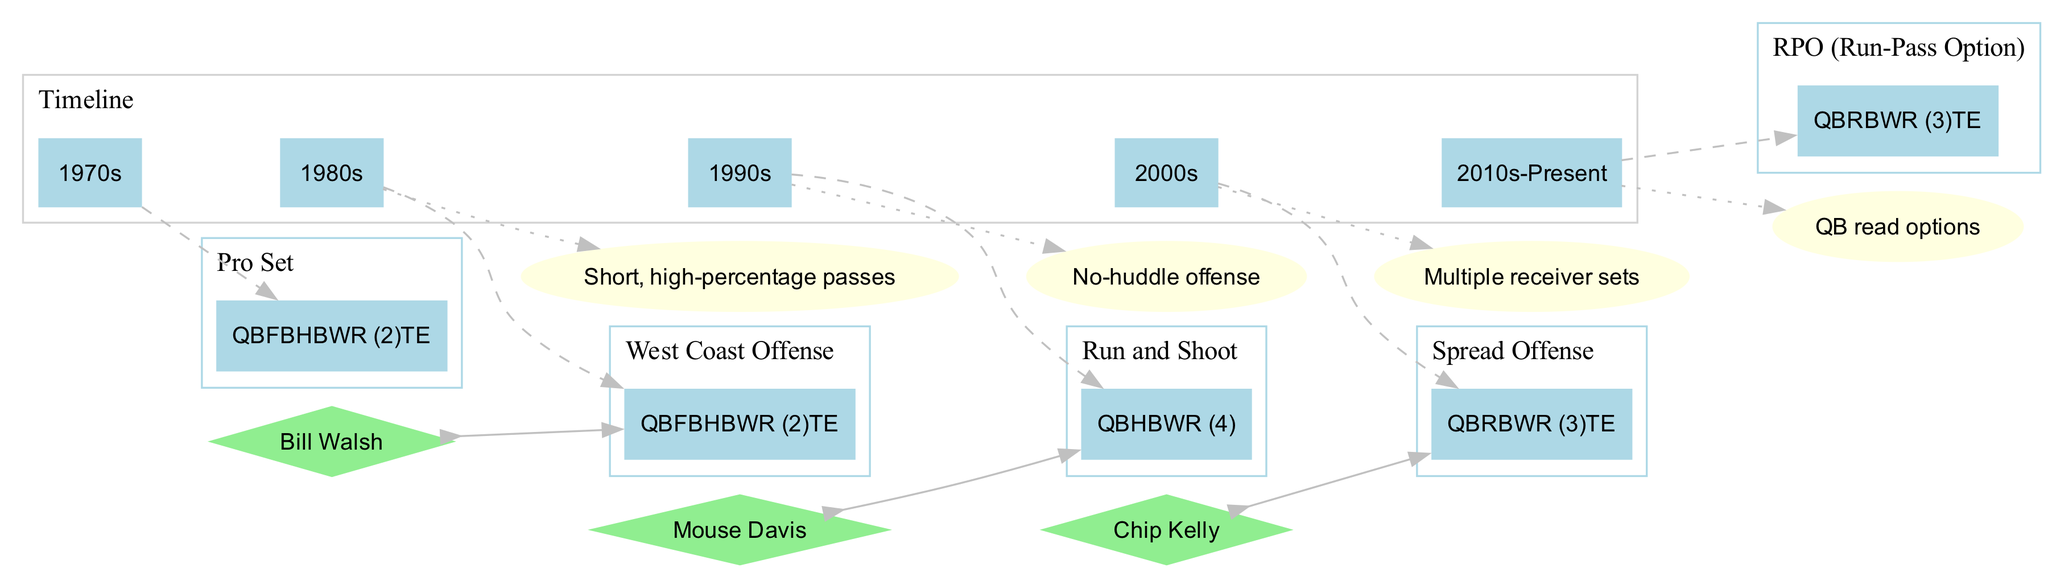What formation is associated with the 1970s? According to the diagram, the formation linked with the 1970s is the Pro Set. This is determined by looking at the section that lists the eras alongside their respective formations.
Answer: Pro Set Who is the notable coordinator associated with the West Coast Offense? The diagram associates Bill Walsh as the notable coordinator for the West Coast Offense, as indicated by the linked diamond shape showing his name next to that formation.
Answer: Bill Walsh What key innovation was introduced in the 2000s? To find the answer, look at the section listing key innovations next to the corresponding timeline eras. The innovation for the 2000s is Multiple receiver sets.
Answer: Multiple receiver sets How many key personnel positions are in the Run and Shoot formation? In the Run and Shoot formation, the diagram shows a total of three key personnel: QB, HB, and WR (4). Counting these, we find there are three distinct positions listed.
Answer: 3 Which offensive formation has four wide receivers? Investigating the formations section reveals that the Run and Shoot formation includes four wide receivers (WR (4)).
Answer: Run and Shoot What graphical shape represents key innovations in the diagram? The diagram uses an ellipse shape to represent key innovations. This can be confirmed by examining the graphical attributes assigned to innovations in the visual structure.
Answer: Ellipse Which era introduced the no-huddle offense? By checking the timeline against the innovations listed, it's found that the no-huddle offense was introduced in the 1990s. The connection between the timeline and innovations provides clarity on this information.
Answer: 1990s How does the Spread Offense relate to Chip Kelly? The diagram establishes a bidirectional edge between Chip Kelly and the Spread Offense, indicating he is a notable coordinator associated with this formation. This connection is made clear visually in the diagram.
Answer: Bidirectional edge In which era is the RPO formation found? The diagram places the RPO (Run-Pass Option) formation under the category of 2010s-Present. This is seen by looking at the formatting clusters for the corresponding time period.
Answer: 2010s-Present 